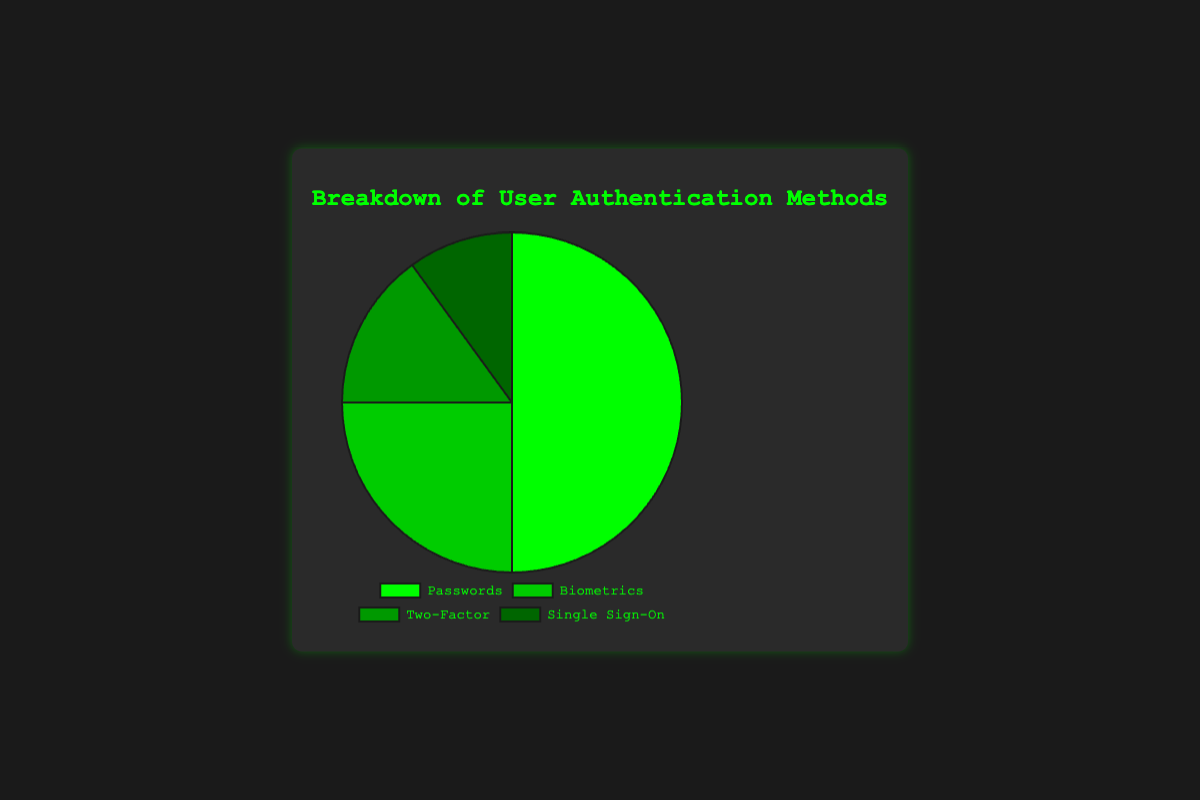What is the most commonly used user authentication method? The figure shows the usage percentages for different authentication methods. The segment with the largest area and label is "Passwords," which is 50%.
Answer: Passwords Which authentication method has the lowest usage percentage? By looking at the figure, the smallest segment with the label "Single Sign-On" corresponds to the smallest percentage of 10%.
Answer: Single Sign-On What is the combined percentage of Two-Factor and Single Sign-On methods? By summing the percentages of Two-Factor (15%) and Single Sign-On (10%), you get 15% + 10% = 25%.
Answer: 25% How does the usage of Biometrics compare to the usage of Two-Factor authentication? Biometrics has a higher percentage (25%) compared to Two-Factor authentication (15%). Comparing these numbers, 25% > 15%.
Answer: Biometrics > Two-Factor Describe the color used to represent the method with the highest percentage. The method with the highest percentage is Passwords, represented by the largest green segment.
Answer: Green What would the new percentage be if Single Sign-On usage doubled? If Single Sign-On usage doubled, it would be 2 * 10% = 20%. The total would then be 50% + 25% + 15% + 20% = 110%. The recalculated percentage of Single Sign-On would be (20/110) * 100 ≈ 18.18%.
Answer: 18.18% Which two authentication methods together make up half of the total usage? Passwords (50%) by itself already makes up half of the total usage, so it takes only one method.
Answer: Passwords What is the relative difference in percentage between the two least used methods? The difference between Two-Factor (15%) and Single Sign-On (10%) is 15% - 10% = 5%. Relative to Single Sign-On’s 10%, the relative difference is (5/10) * 100 = 50%.
Answer: 50% What fraction of the chart is represented by Biometrics? Biometrics occupies 25% of the chart, which as a fraction is 25/100, simplifying to 1/4.
Answer: 1/4 